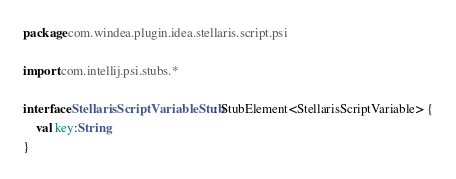<code> <loc_0><loc_0><loc_500><loc_500><_Kotlin_>package com.windea.plugin.idea.stellaris.script.psi

import com.intellij.psi.stubs.*

interface StellarisScriptVariableStub: StubElement<StellarisScriptVariable> {
	val key:String
}
</code> 